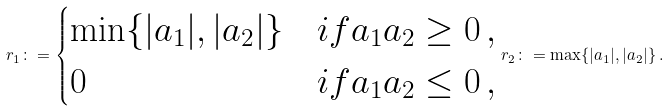<formula> <loc_0><loc_0><loc_500><loc_500>r _ { 1 } \colon = \begin{cases} \min \{ | a _ { 1 } | , | a _ { 2 } | \} & i f a _ { 1 } a _ { 2 } \geq 0 \, , \\ 0 & i f a _ { 1 } a _ { 2 } \leq 0 \, , \end{cases} r _ { 2 } \colon = \max \{ | a _ { 1 } | , | a _ { 2 } | \} \, .</formula> 